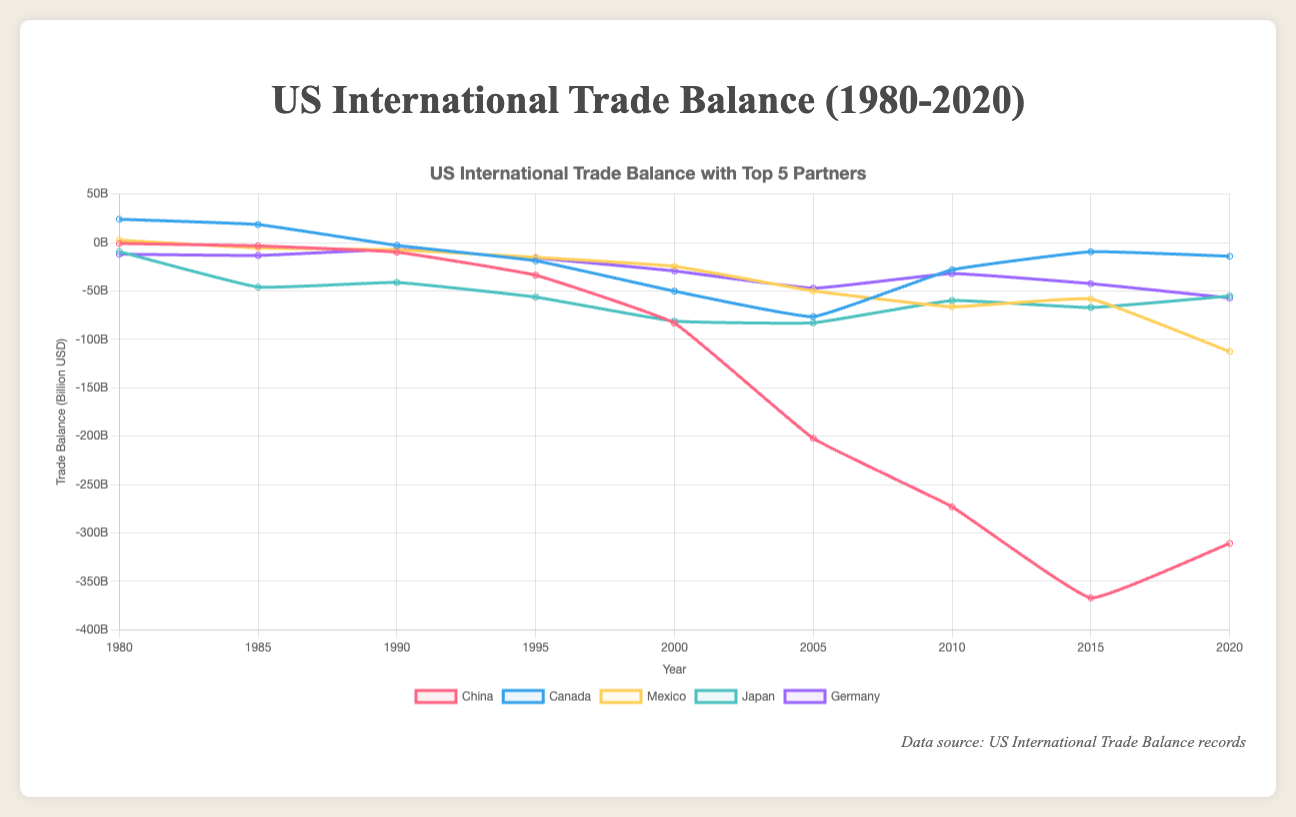What was the trade balance between the US and China in 2020? From the chart, locate the data point labeled "China" under the year 2020. The value at this point reflects the trade balance.
Answer: -310.8 billion USD How did the trade balance with Japan change from 1980 to 2020? Compare the trade balance value under the "Japan" label for the years 1980 and 2020. The change can be calculated by subtracting the 1980 value from the 2020 value.
Answer: -45.8 billion USD Which country had the smallest trade deficit with the US in 1990? Examine the chart for the data points under the year 1990. The country with the value closest to zero has the smallest deficit.
Answer: Mexico In which year did the US have the largest trade deficit with Germany? Scan the chart for the data points labeled "Germany" and identify the year with the most negative value.
Answer: 2020 What was the overall trend in the trade balance with China from 1980 to 2020? Observe the line on the graph representing China from 1980 to 2020. Identify whether the values are generally increasing or decreasing.
Answer: Decreasing (more negative) How does the trade deficit with Mexico in 2020 compare to that in 1995? Look at the trade balance values for Mexico in 1995 and 2020. Compare the two values to see the change.
Answer: The deficit increased (more negative in 2020) Which country had a positive trade balance with the US at some point between 1980 and 2020? Observe the lines representing each country and look for any instance where the line is above the horizontal (zero) line.
Answer: Canada Between which years did the trade balance with Canada see the most significant drop? Identify the periods for Canada where the slope of the line is steepest in the downward direction.
Answer: 1980 to 1990 Which country had the most volatile trade balance with the US? Look at the lines for each country and identify the one with the largest fluctuations in values over time.
Answer: Canada How did the trade balance with Germany evolve from 1995 to 2005? Compare the values for Germany in 1995 and 2005 and describe the trend between those years.
Answer: The deficit increased (became more negative) 